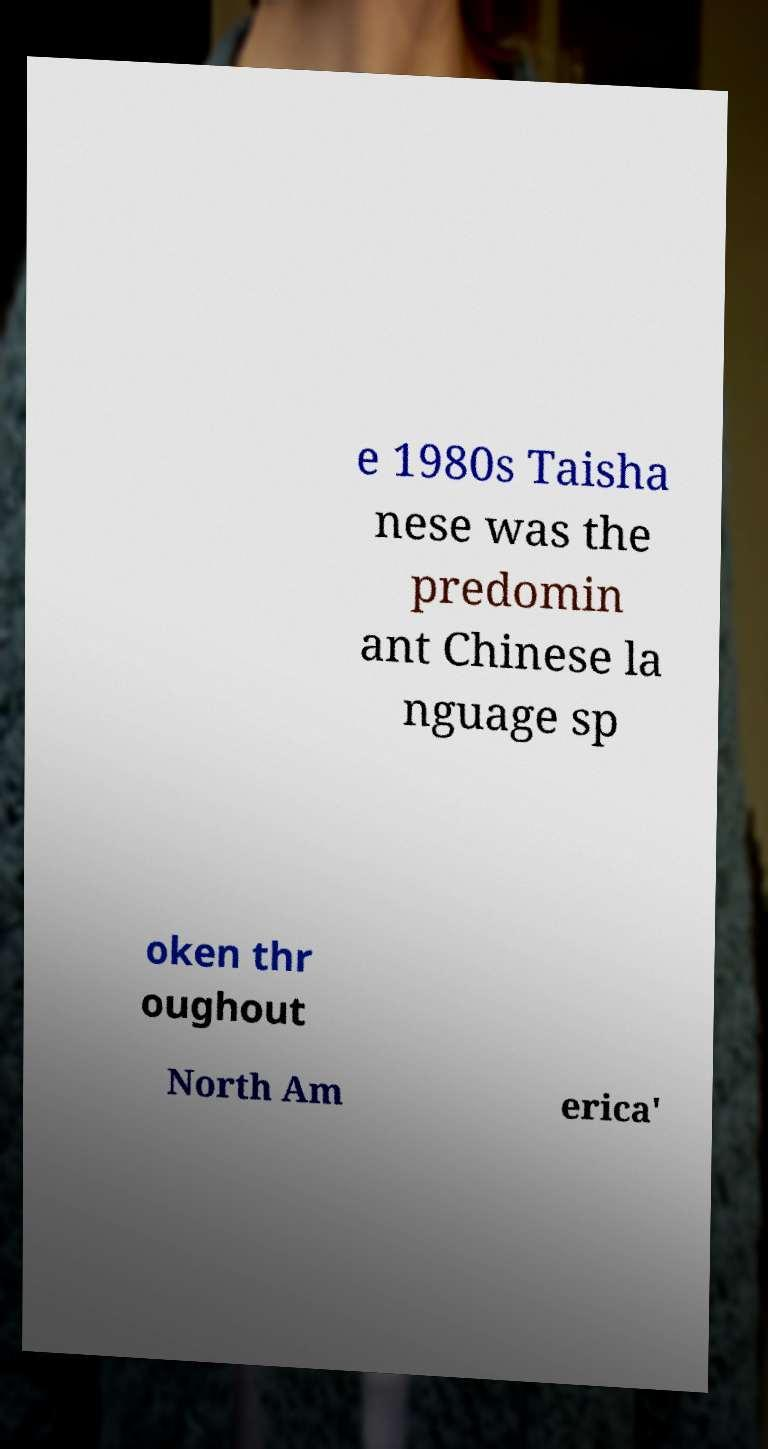Could you extract and type out the text from this image? e 1980s Taisha nese was the predomin ant Chinese la nguage sp oken thr oughout North Am erica' 